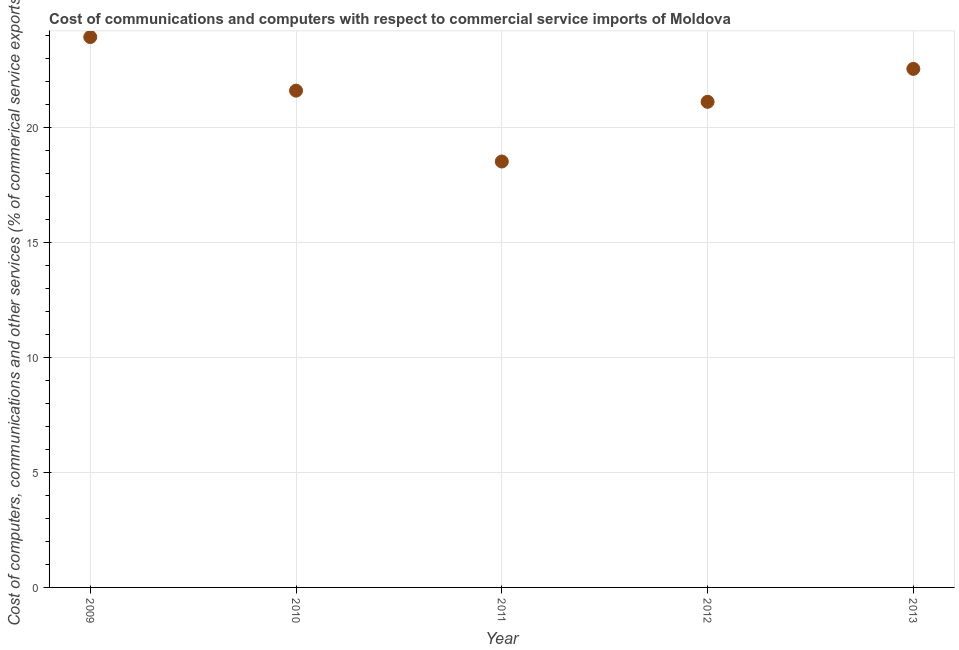What is the  computer and other services in 2010?
Give a very brief answer. 21.6. Across all years, what is the maximum  computer and other services?
Offer a very short reply. 23.94. Across all years, what is the minimum cost of communications?
Your response must be concise. 18.52. In which year was the  computer and other services maximum?
Give a very brief answer. 2009. What is the sum of the  computer and other services?
Ensure brevity in your answer.  107.73. What is the difference between the cost of communications in 2009 and 2011?
Offer a terse response. 5.41. What is the average  computer and other services per year?
Provide a short and direct response. 21.55. What is the median cost of communications?
Your answer should be very brief. 21.6. What is the ratio of the cost of communications in 2011 to that in 2013?
Provide a short and direct response. 0.82. What is the difference between the highest and the second highest  computer and other services?
Your answer should be very brief. 1.38. What is the difference between the highest and the lowest cost of communications?
Make the answer very short. 5.41. How many years are there in the graph?
Provide a succinct answer. 5. Does the graph contain any zero values?
Offer a very short reply. No. What is the title of the graph?
Keep it short and to the point. Cost of communications and computers with respect to commercial service imports of Moldova. What is the label or title of the X-axis?
Provide a short and direct response. Year. What is the label or title of the Y-axis?
Give a very brief answer. Cost of computers, communications and other services (% of commerical service exports). What is the Cost of computers, communications and other services (% of commerical service exports) in 2009?
Provide a short and direct response. 23.94. What is the Cost of computers, communications and other services (% of commerical service exports) in 2010?
Provide a succinct answer. 21.6. What is the Cost of computers, communications and other services (% of commerical service exports) in 2011?
Your answer should be very brief. 18.52. What is the Cost of computers, communications and other services (% of commerical service exports) in 2012?
Offer a terse response. 21.12. What is the Cost of computers, communications and other services (% of commerical service exports) in 2013?
Provide a succinct answer. 22.55. What is the difference between the Cost of computers, communications and other services (% of commerical service exports) in 2009 and 2010?
Your answer should be compact. 2.33. What is the difference between the Cost of computers, communications and other services (% of commerical service exports) in 2009 and 2011?
Your answer should be very brief. 5.41. What is the difference between the Cost of computers, communications and other services (% of commerical service exports) in 2009 and 2012?
Provide a succinct answer. 2.82. What is the difference between the Cost of computers, communications and other services (% of commerical service exports) in 2009 and 2013?
Your response must be concise. 1.38. What is the difference between the Cost of computers, communications and other services (% of commerical service exports) in 2010 and 2011?
Your answer should be compact. 3.08. What is the difference between the Cost of computers, communications and other services (% of commerical service exports) in 2010 and 2012?
Give a very brief answer. 0.49. What is the difference between the Cost of computers, communications and other services (% of commerical service exports) in 2010 and 2013?
Make the answer very short. -0.95. What is the difference between the Cost of computers, communications and other services (% of commerical service exports) in 2011 and 2012?
Keep it short and to the point. -2.6. What is the difference between the Cost of computers, communications and other services (% of commerical service exports) in 2011 and 2013?
Offer a very short reply. -4.03. What is the difference between the Cost of computers, communications and other services (% of commerical service exports) in 2012 and 2013?
Your answer should be compact. -1.43. What is the ratio of the Cost of computers, communications and other services (% of commerical service exports) in 2009 to that in 2010?
Keep it short and to the point. 1.11. What is the ratio of the Cost of computers, communications and other services (% of commerical service exports) in 2009 to that in 2011?
Provide a succinct answer. 1.29. What is the ratio of the Cost of computers, communications and other services (% of commerical service exports) in 2009 to that in 2012?
Make the answer very short. 1.13. What is the ratio of the Cost of computers, communications and other services (% of commerical service exports) in 2009 to that in 2013?
Your answer should be compact. 1.06. What is the ratio of the Cost of computers, communications and other services (% of commerical service exports) in 2010 to that in 2011?
Make the answer very short. 1.17. What is the ratio of the Cost of computers, communications and other services (% of commerical service exports) in 2010 to that in 2013?
Ensure brevity in your answer.  0.96. What is the ratio of the Cost of computers, communications and other services (% of commerical service exports) in 2011 to that in 2012?
Your answer should be compact. 0.88. What is the ratio of the Cost of computers, communications and other services (% of commerical service exports) in 2011 to that in 2013?
Your answer should be compact. 0.82. What is the ratio of the Cost of computers, communications and other services (% of commerical service exports) in 2012 to that in 2013?
Your answer should be compact. 0.94. 